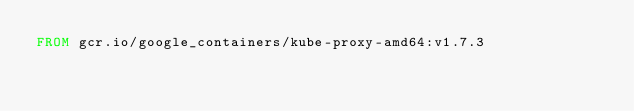<code> <loc_0><loc_0><loc_500><loc_500><_Dockerfile_>FROM gcr.io/google_containers/kube-proxy-amd64:v1.7.3
</code> 